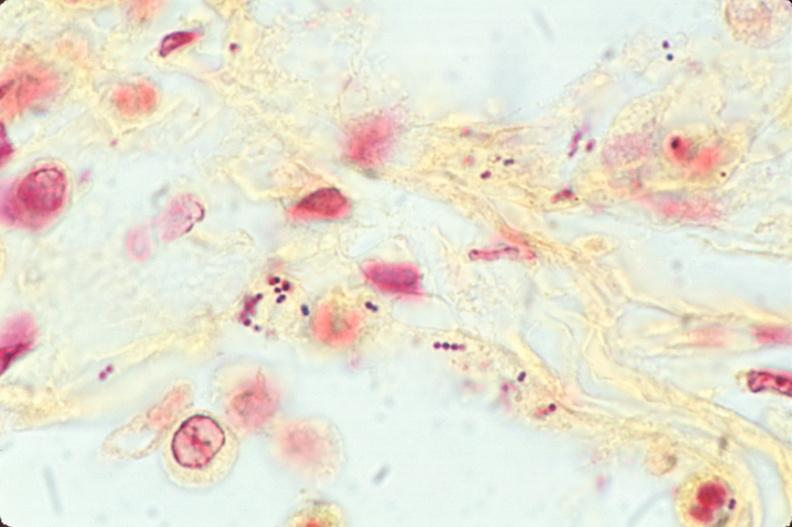what stain?
Answer the question using a single word or phrase. This image shows lung 